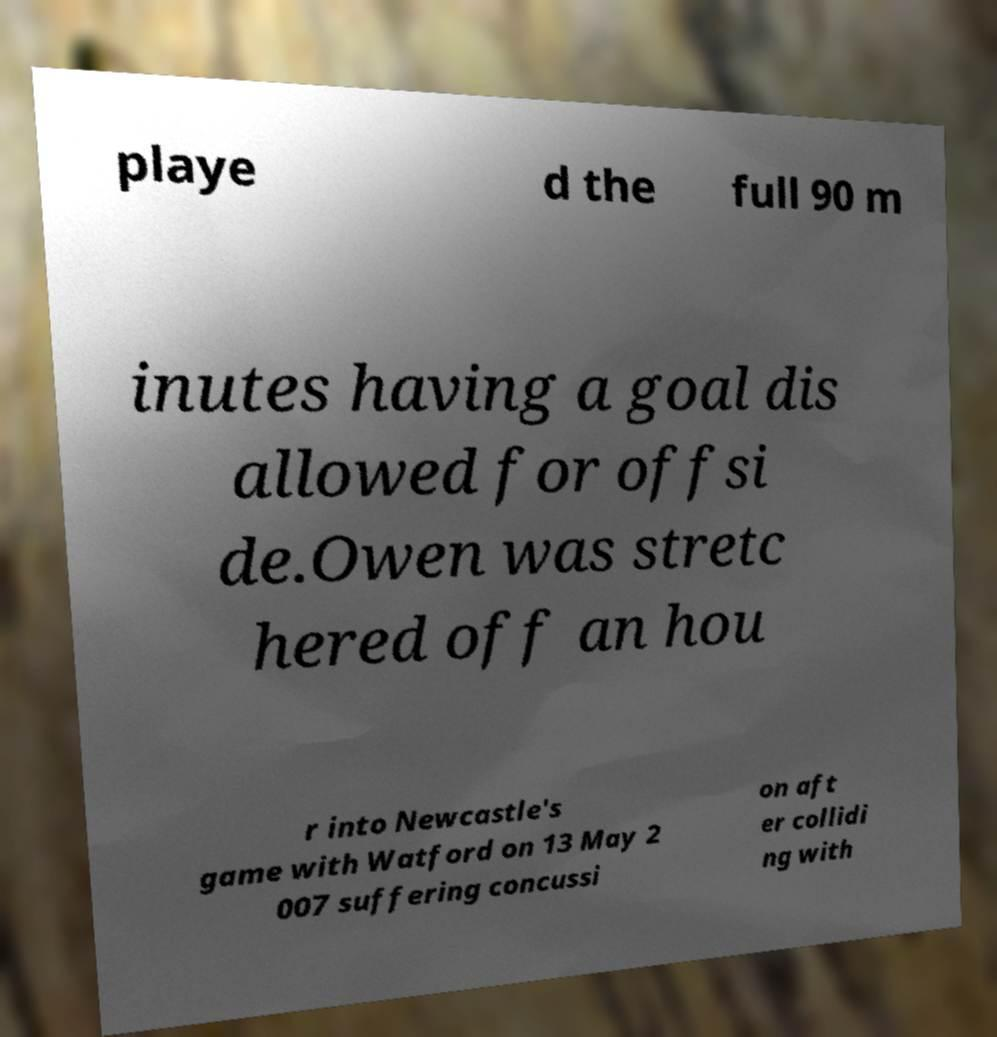Can you accurately transcribe the text from the provided image for me? playe d the full 90 m inutes having a goal dis allowed for offsi de.Owen was stretc hered off an hou r into Newcastle's game with Watford on 13 May 2 007 suffering concussi on aft er collidi ng with 